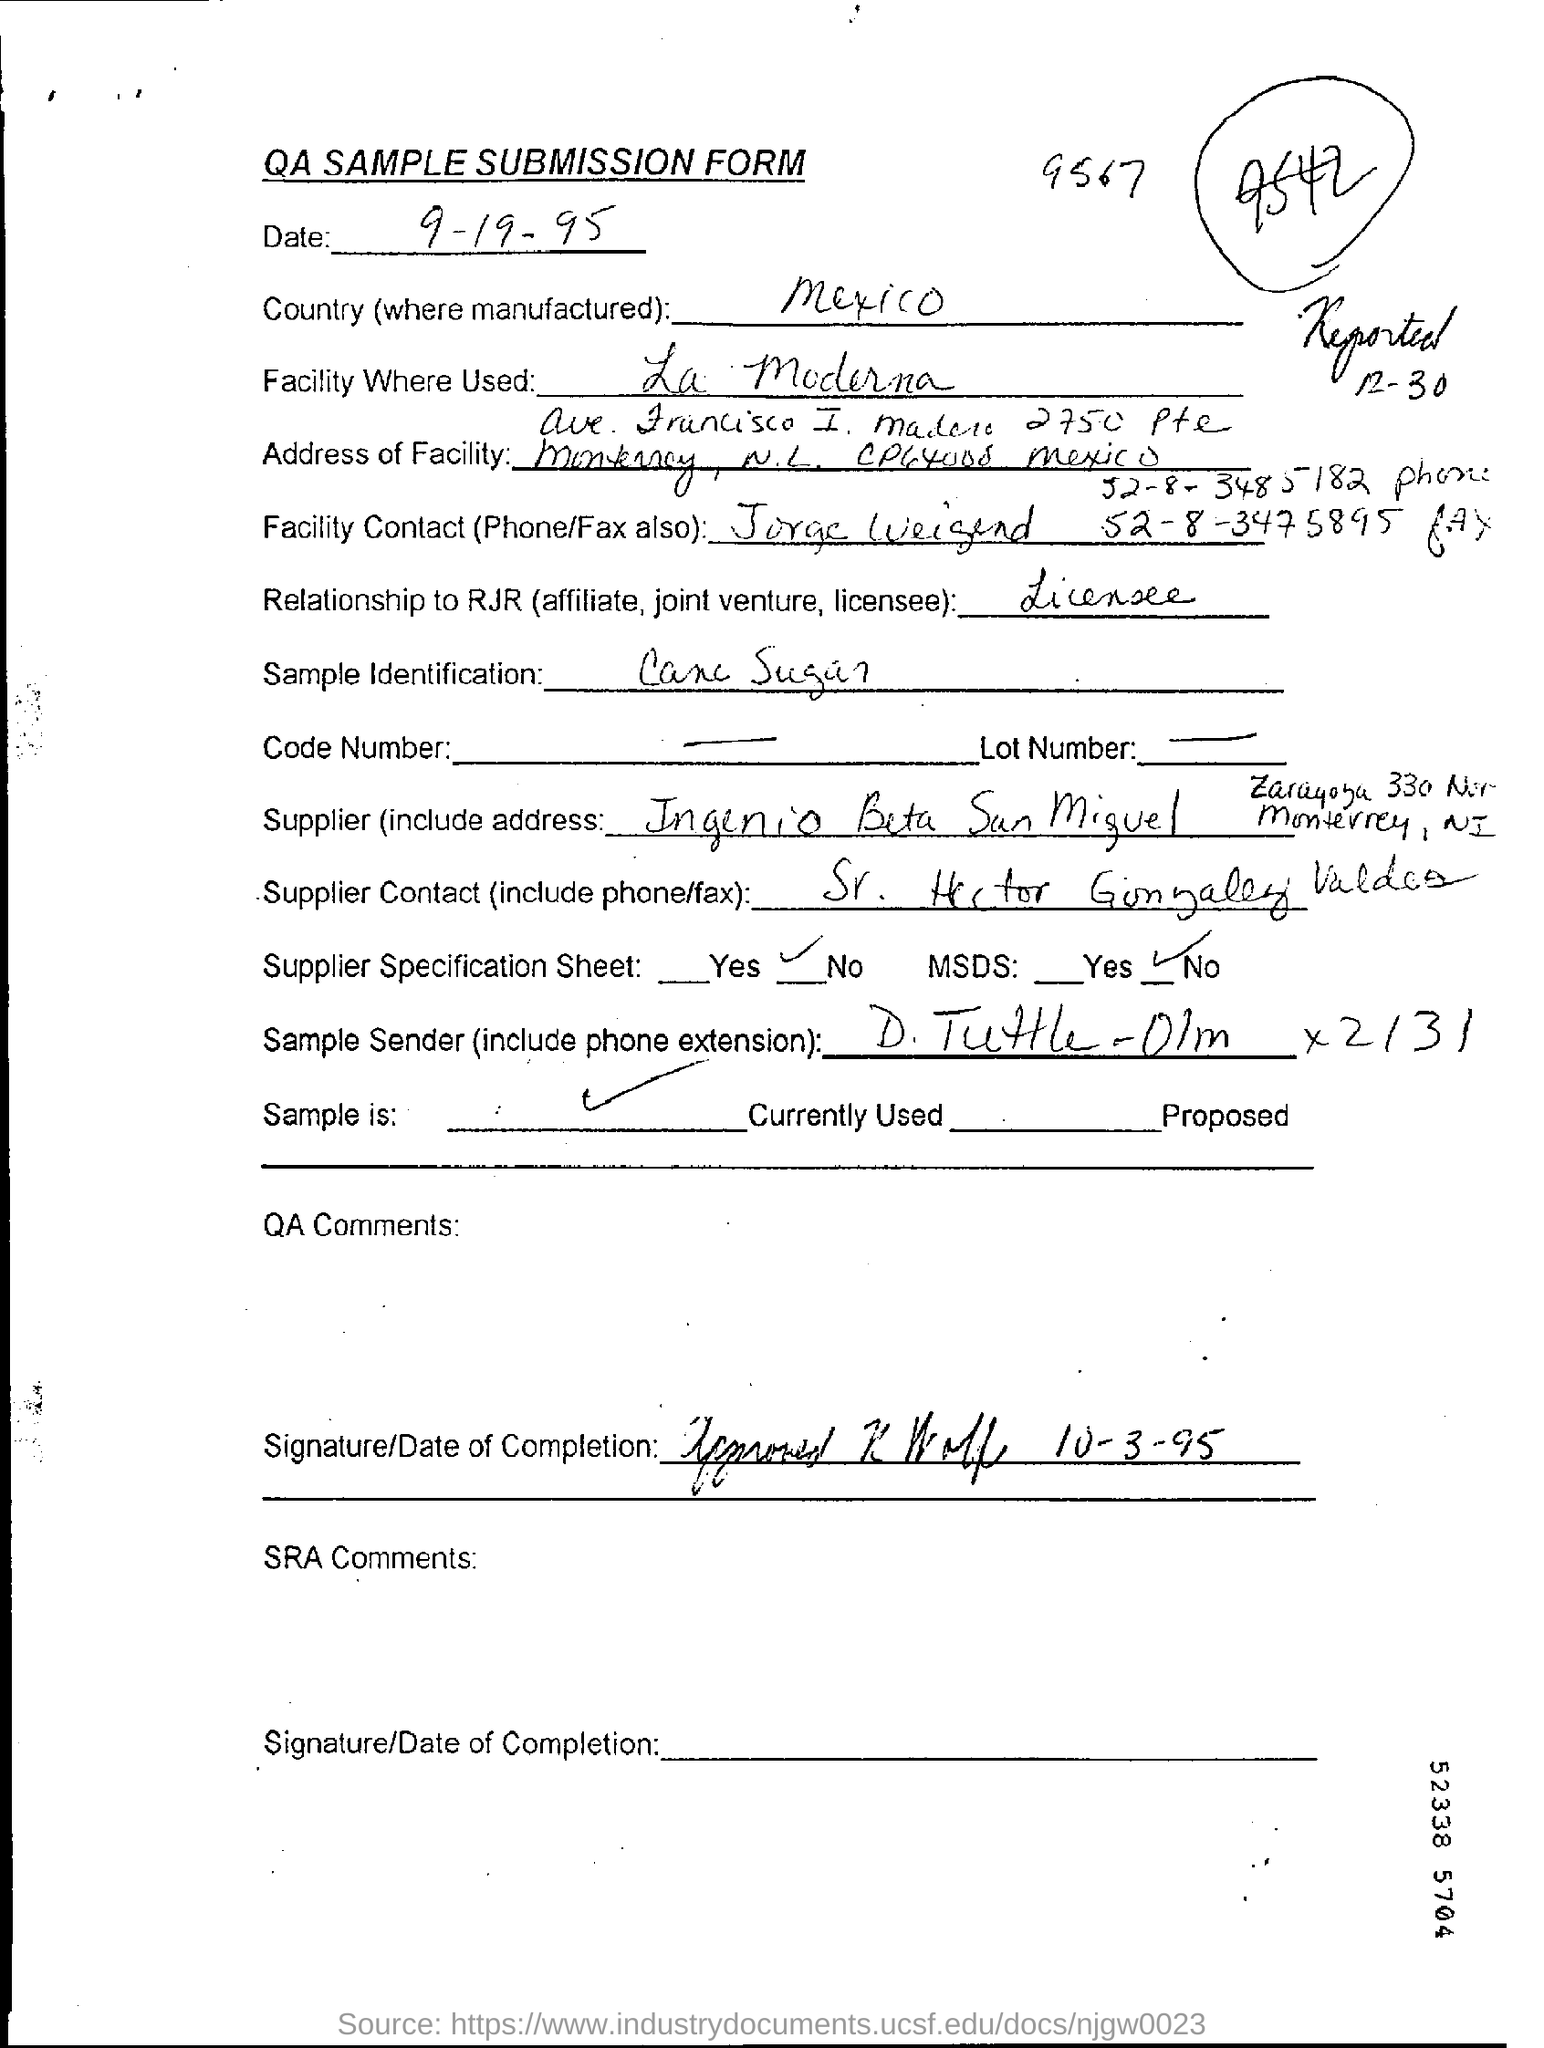Which form is this ?
Your answer should be very brief. QA SAMPLE SUBMISSION FORM. In which country it is manufactured ?
Make the answer very short. Mexico. Which sample is used for identification ?
Provide a short and direct response. Cane Sugar. 